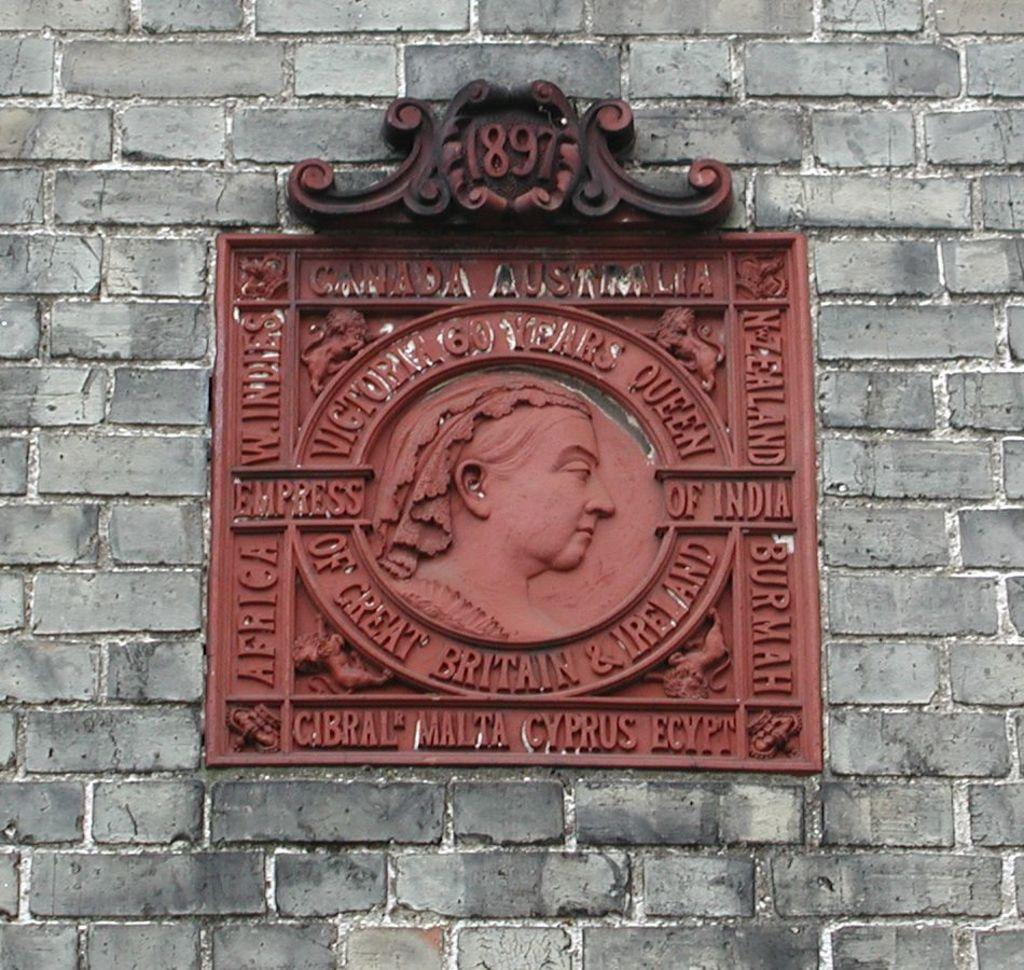What is depicted in the carving image in the picture? There is a carving image of a person in the picture. Where is the carving located? The carving is attached to a wall. What else can be seen near the carving? There are words written near the carving. What type of structure is the wall part of? The wall is part of a building. What type of whistle can be heard coming from the carving in the image? There is no whistle present in the image, as it features a carving of a person and words written near it. 